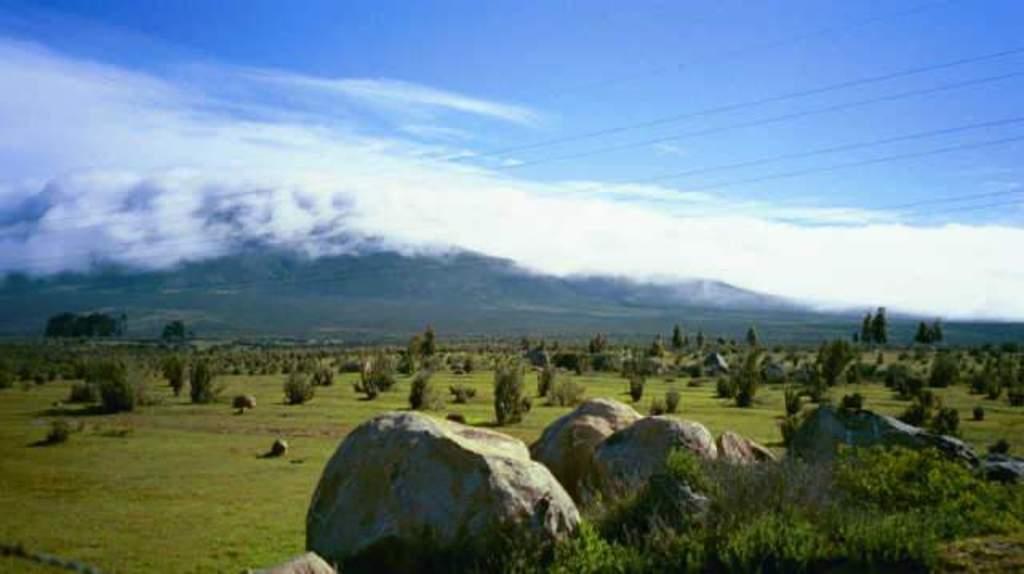How would you summarize this image in a sentence or two? In this picture we can see rocks, plants, grass, trees and wires. In the background of the image we can see sky with clouds. 